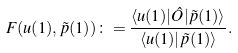Convert formula to latex. <formula><loc_0><loc_0><loc_500><loc_500>F ( { u } ( 1 ) , \tilde { p } ( 1 ) ) \colon = \frac { \langle { u } ( 1 ) | \hat { O } | \tilde { p } ( 1 ) \rangle } { \langle { u } ( 1 ) | \tilde { p } ( 1 ) \rangle } .</formula> 